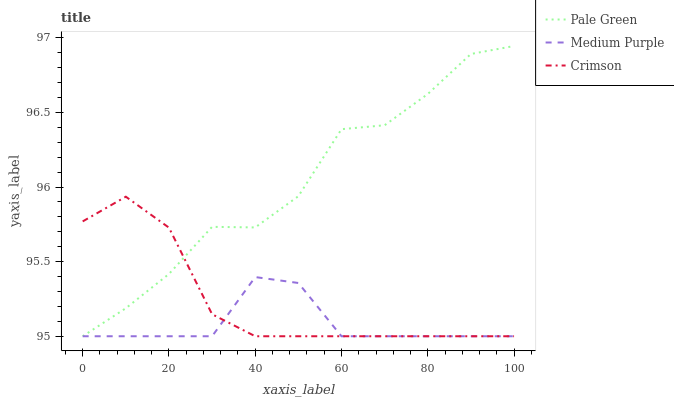Does Medium Purple have the minimum area under the curve?
Answer yes or no. Yes. Does Pale Green have the maximum area under the curve?
Answer yes or no. Yes. Does Crimson have the minimum area under the curve?
Answer yes or no. No. Does Crimson have the maximum area under the curve?
Answer yes or no. No. Is Crimson the smoothest?
Answer yes or no. Yes. Is Pale Green the roughest?
Answer yes or no. Yes. Is Pale Green the smoothest?
Answer yes or no. No. Is Crimson the roughest?
Answer yes or no. No. Does Medium Purple have the lowest value?
Answer yes or no. Yes. Does Pale Green have the highest value?
Answer yes or no. Yes. Does Crimson have the highest value?
Answer yes or no. No. Does Crimson intersect Pale Green?
Answer yes or no. Yes. Is Crimson less than Pale Green?
Answer yes or no. No. Is Crimson greater than Pale Green?
Answer yes or no. No. 